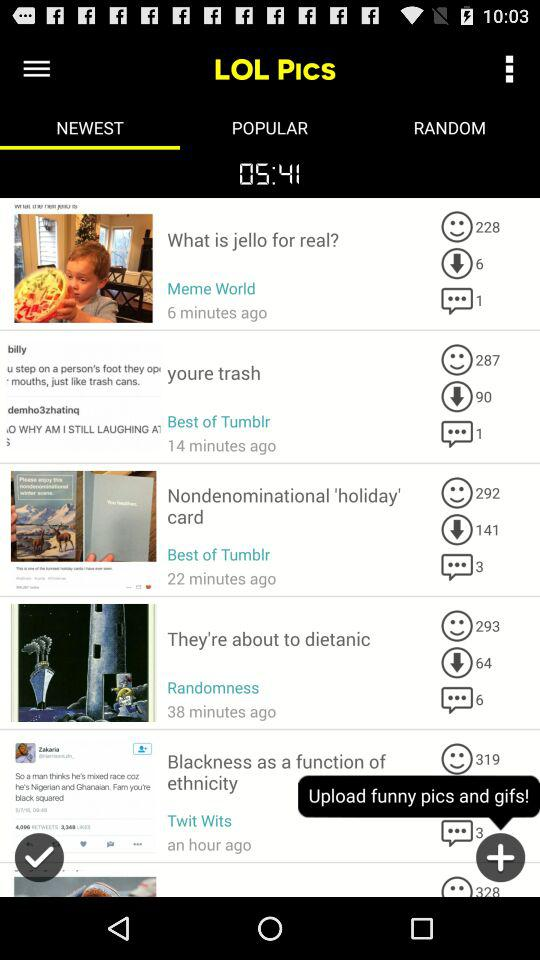Which post has 141 downloads? The post that has 141 downloads is "Nondenominational 'holiday' card". 